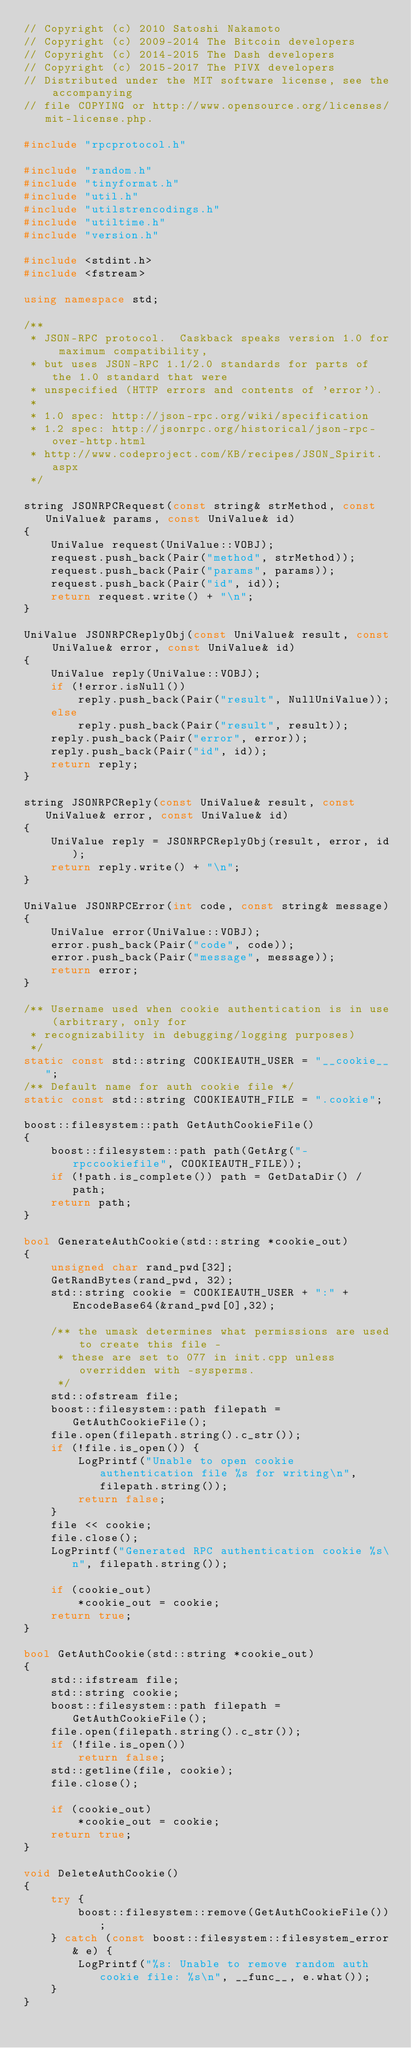<code> <loc_0><loc_0><loc_500><loc_500><_C++_>// Copyright (c) 2010 Satoshi Nakamoto
// Copyright (c) 2009-2014 The Bitcoin developers
// Copyright (c) 2014-2015 The Dash developers
// Copyright (c) 2015-2017 The PIVX developers
// Distributed under the MIT software license, see the accompanying
// file COPYING or http://www.opensource.org/licenses/mit-license.php.

#include "rpcprotocol.h"

#include "random.h"
#include "tinyformat.h"
#include "util.h"
#include "utilstrencodings.h"
#include "utiltime.h"
#include "version.h"

#include <stdint.h>
#include <fstream>

using namespace std;

/**
 * JSON-RPC protocol.  Caskback speaks version 1.0 for maximum compatibility,
 * but uses JSON-RPC 1.1/2.0 standards for parts of the 1.0 standard that were
 * unspecified (HTTP errors and contents of 'error').
 *
 * 1.0 spec: http://json-rpc.org/wiki/specification
 * 1.2 spec: http://jsonrpc.org/historical/json-rpc-over-http.html
 * http://www.codeproject.com/KB/recipes/JSON_Spirit.aspx
 */

string JSONRPCRequest(const string& strMethod, const UniValue& params, const UniValue& id)
{
    UniValue request(UniValue::VOBJ);
    request.push_back(Pair("method", strMethod));
    request.push_back(Pair("params", params));
    request.push_back(Pair("id", id));
    return request.write() + "\n";
}

UniValue JSONRPCReplyObj(const UniValue& result, const UniValue& error, const UniValue& id)
{
    UniValue reply(UniValue::VOBJ);
    if (!error.isNull())
        reply.push_back(Pair("result", NullUniValue));
    else
        reply.push_back(Pair("result", result));
    reply.push_back(Pair("error", error));
    reply.push_back(Pair("id", id));
    return reply;
}

string JSONRPCReply(const UniValue& result, const UniValue& error, const UniValue& id)
{
    UniValue reply = JSONRPCReplyObj(result, error, id);
    return reply.write() + "\n";
}

UniValue JSONRPCError(int code, const string& message)
{
    UniValue error(UniValue::VOBJ);
    error.push_back(Pair("code", code));
    error.push_back(Pair("message", message));
    return error;
}

/** Username used when cookie authentication is in use (arbitrary, only for
 * recognizability in debugging/logging purposes)
 */
static const std::string COOKIEAUTH_USER = "__cookie__";
/** Default name for auth cookie file */
static const std::string COOKIEAUTH_FILE = ".cookie";

boost::filesystem::path GetAuthCookieFile()
{
    boost::filesystem::path path(GetArg("-rpccookiefile", COOKIEAUTH_FILE));
    if (!path.is_complete()) path = GetDataDir() / path;
    return path;
}

bool GenerateAuthCookie(std::string *cookie_out)
{
    unsigned char rand_pwd[32];
    GetRandBytes(rand_pwd, 32);
    std::string cookie = COOKIEAUTH_USER + ":" + EncodeBase64(&rand_pwd[0],32);

    /** the umask determines what permissions are used to create this file -
     * these are set to 077 in init.cpp unless overridden with -sysperms.
     */
    std::ofstream file;
    boost::filesystem::path filepath = GetAuthCookieFile();
    file.open(filepath.string().c_str());
    if (!file.is_open()) {
        LogPrintf("Unable to open cookie authentication file %s for writing\n", filepath.string());
        return false;
    }
    file << cookie;
    file.close();
    LogPrintf("Generated RPC authentication cookie %s\n", filepath.string());

    if (cookie_out)
        *cookie_out = cookie;
    return true;
}

bool GetAuthCookie(std::string *cookie_out)
{
    std::ifstream file;
    std::string cookie;
    boost::filesystem::path filepath = GetAuthCookieFile();
    file.open(filepath.string().c_str());
    if (!file.is_open())
        return false;
    std::getline(file, cookie);
    file.close();

    if (cookie_out)
        *cookie_out = cookie;
    return true;
}

void DeleteAuthCookie()
{
    try {
        boost::filesystem::remove(GetAuthCookieFile());
    } catch (const boost::filesystem::filesystem_error& e) {
        LogPrintf("%s: Unable to remove random auth cookie file: %s\n", __func__, e.what());
    }
}
</code> 